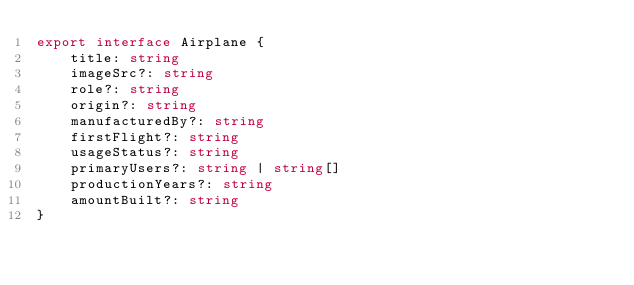Convert code to text. <code><loc_0><loc_0><loc_500><loc_500><_TypeScript_>export interface Airplane {
    title: string
    imageSrc?: string
    role?: string
    origin?: string
    manufacturedBy?: string
    firstFlight?: string
    usageStatus?: string
    primaryUsers?: string | string[]
    productionYears?: string
    amountBuilt?: string
}
</code> 